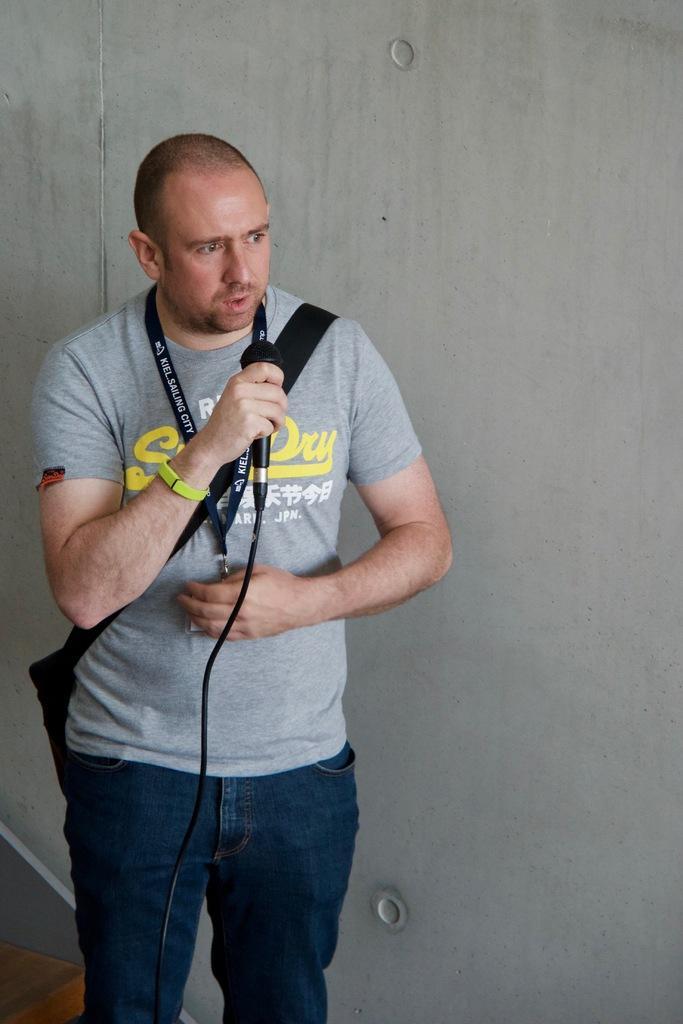In one or two sentences, can you explain what this image depicts? In this image, In the left side there is a man he is standing and he is holding a microphone which is in black color and in the right side there is a wall which is in white color. 